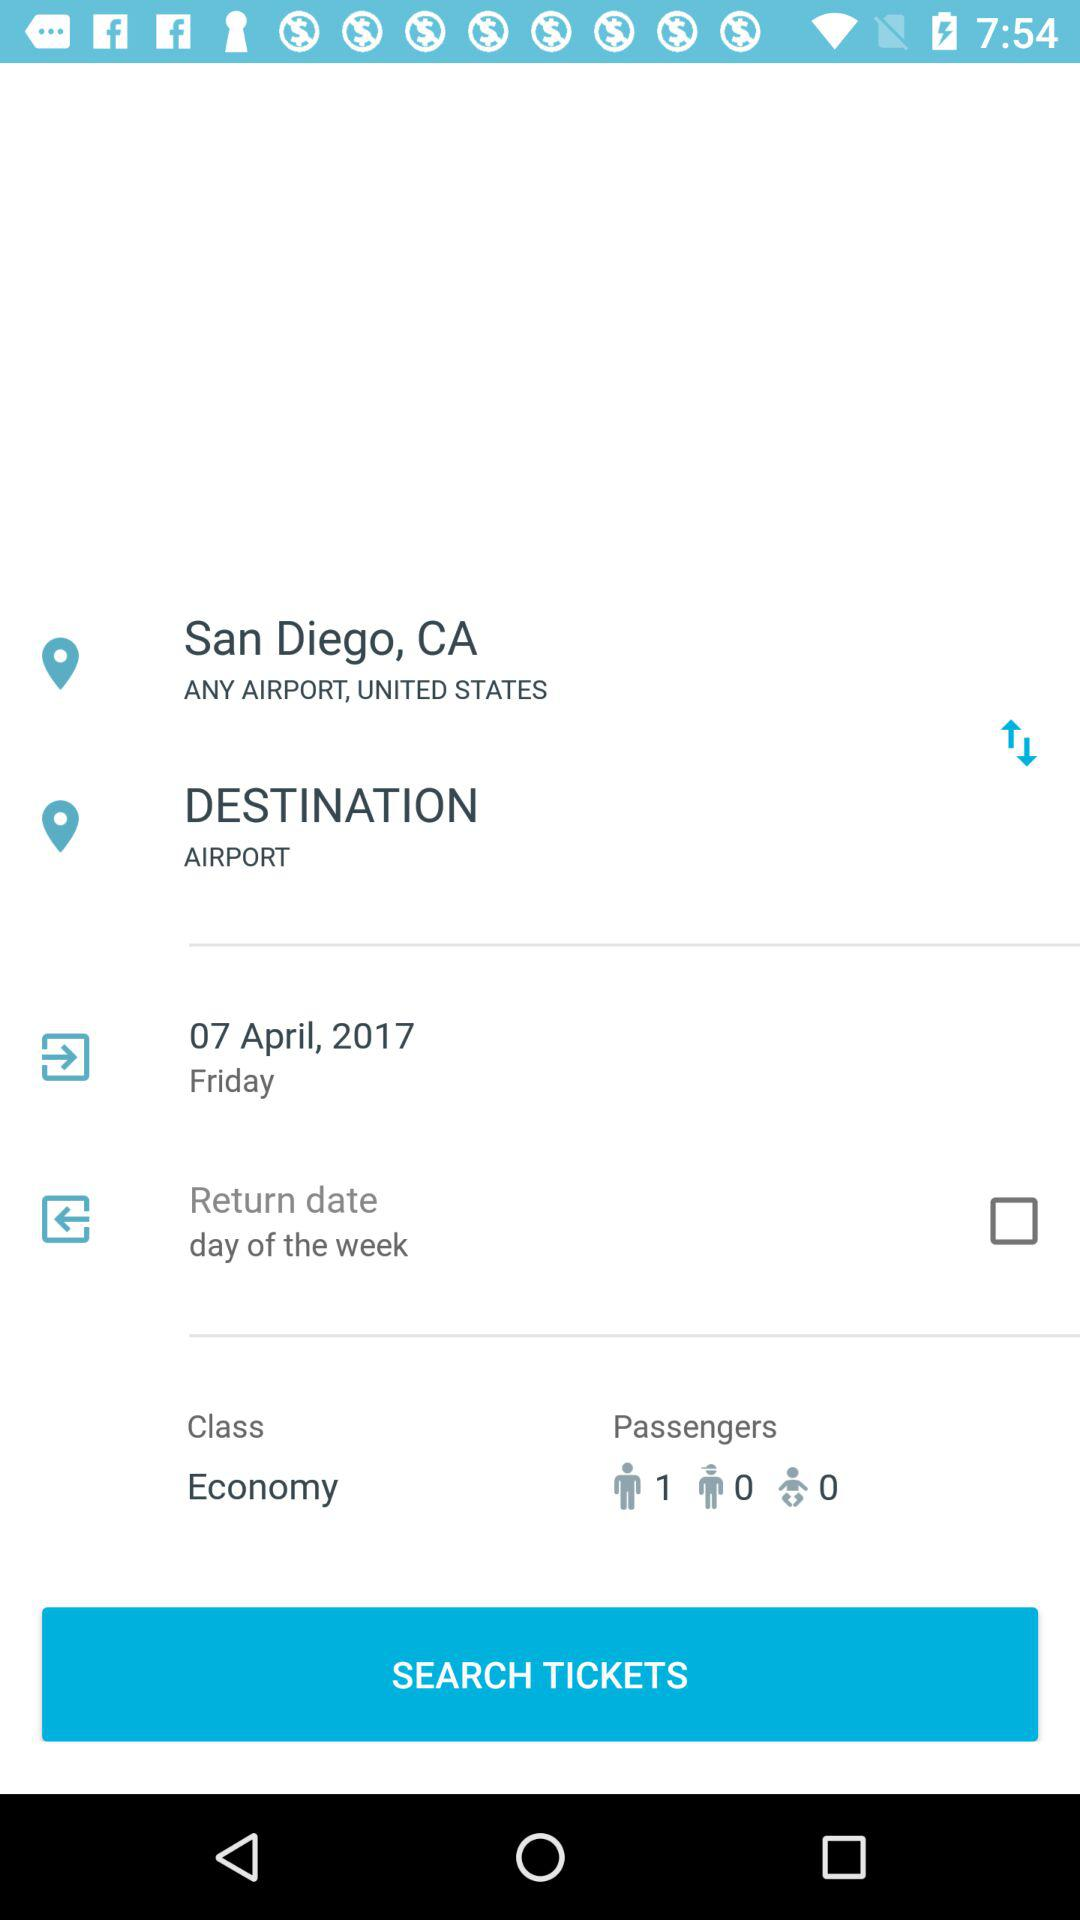How many passengers are traveling?
Answer the question using a single word or phrase. 1 